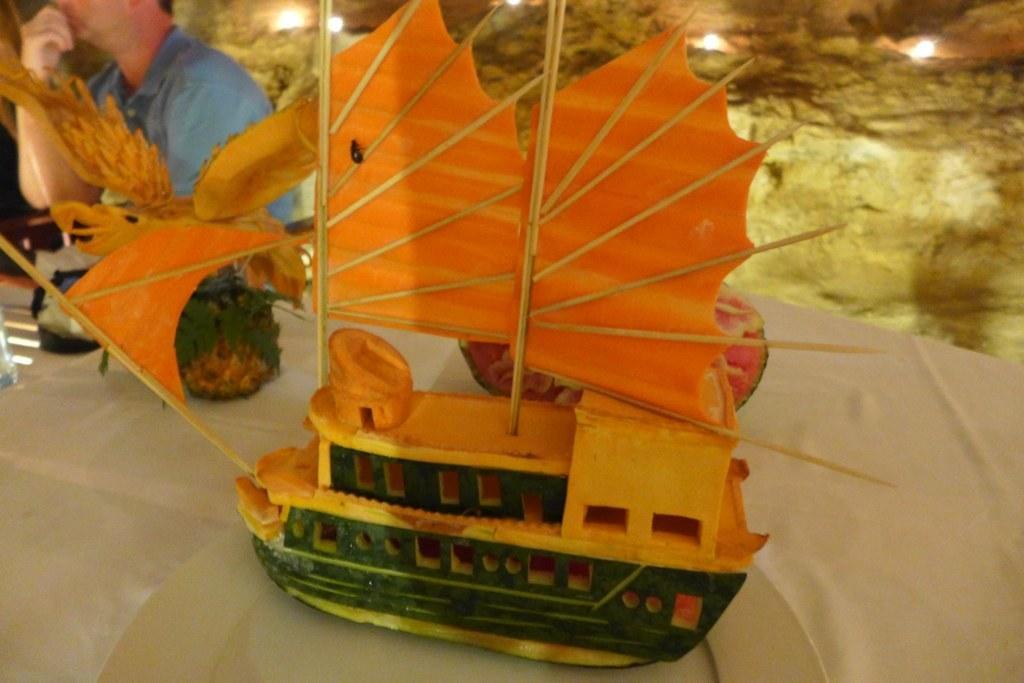Can you describe this image briefly? In this picture we can see a toy boat made with fruits which is on a cloth. Here we can see a person. 